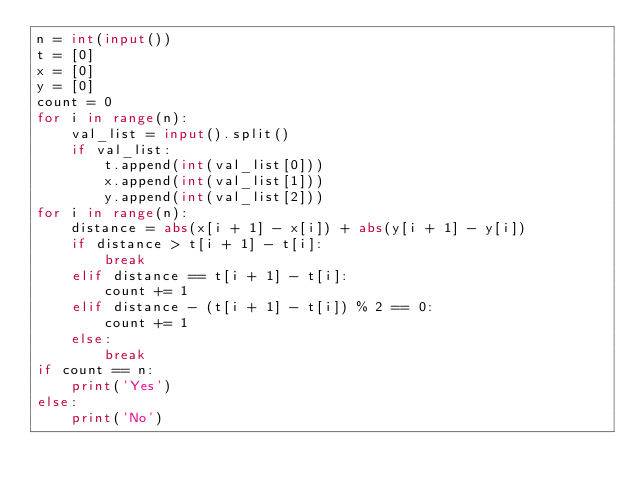<code> <loc_0><loc_0><loc_500><loc_500><_Python_>n = int(input())
t = [0]
x = [0]
y = [0]
count = 0
for i in range(n):
    val_list = input().split()
    if val_list:
        t.append(int(val_list[0]))
        x.append(int(val_list[1]))
        y.append(int(val_list[2]))
for i in range(n):
    distance = abs(x[i + 1] - x[i]) + abs(y[i + 1] - y[i])
    if distance > t[i + 1] - t[i]:
        break
    elif distance == t[i + 1] - t[i]:
        count += 1
    elif distance - (t[i + 1] - t[i]) % 2 == 0:
        count += 1
    else:
        break
if count == n:
    print('Yes')
else:
    print('No')
</code> 